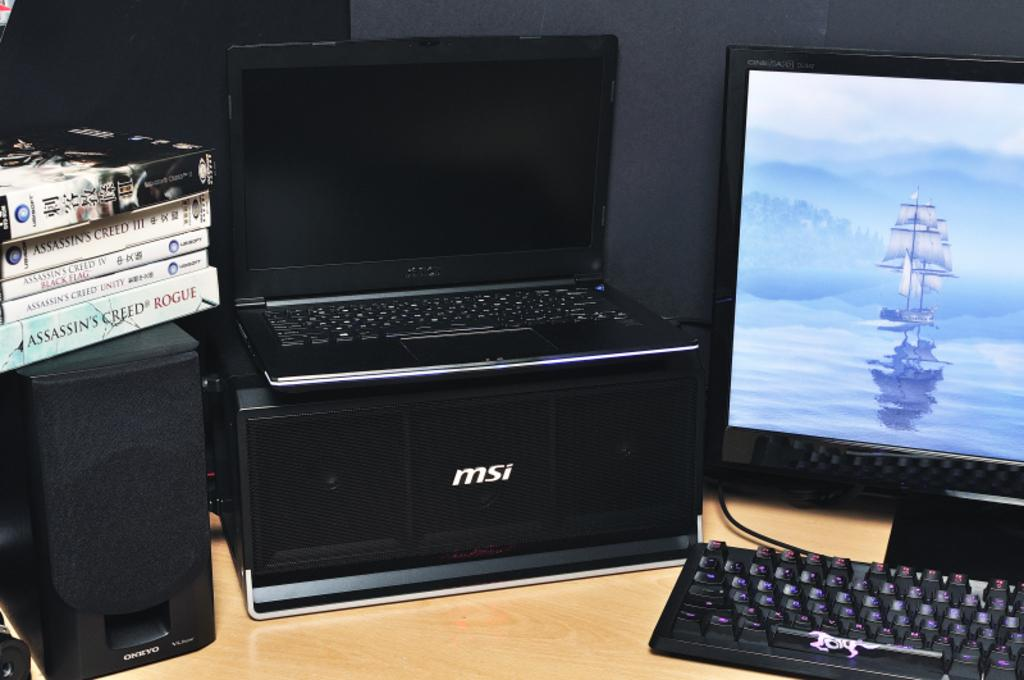<image>
Provide a brief description of the given image. A MSI speaker, holding a black laptop computer. 